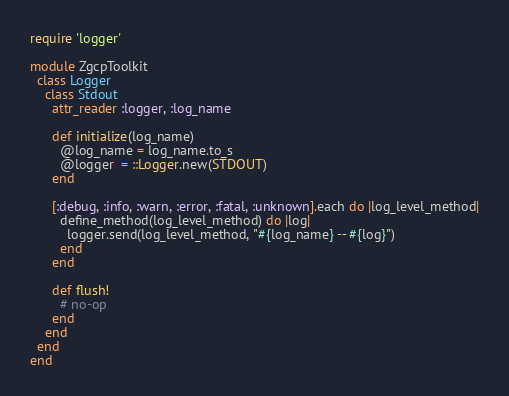<code> <loc_0><loc_0><loc_500><loc_500><_Ruby_>require 'logger'

module ZgcpToolkit
  class Logger 
    class Stdout
      attr_reader :logger, :log_name

      def initialize(log_name)
        @log_name = log_name.to_s
        @logger  = ::Logger.new(STDOUT)
      end

      [:debug, :info, :warn, :error, :fatal, :unknown].each do |log_level_method|
        define_method(log_level_method) do |log|
          logger.send(log_level_method, "#{log_name} -- #{log}")
        end
      end

      def flush!
        # no-op
      end
    end
  end
end
</code> 